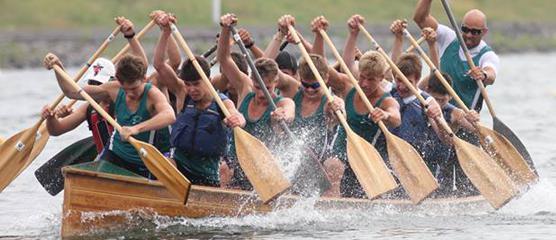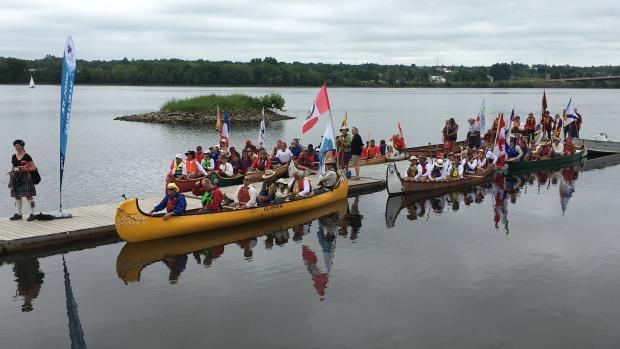The first image is the image on the left, the second image is the image on the right. Evaluate the accuracy of this statement regarding the images: "One of the boats is red.". Is it true? Answer yes or no. No. The first image is the image on the left, the second image is the image on the right. Considering the images on both sides, is "In 1 of the images, the oars are kicking up spray." valid? Answer yes or no. Yes. 